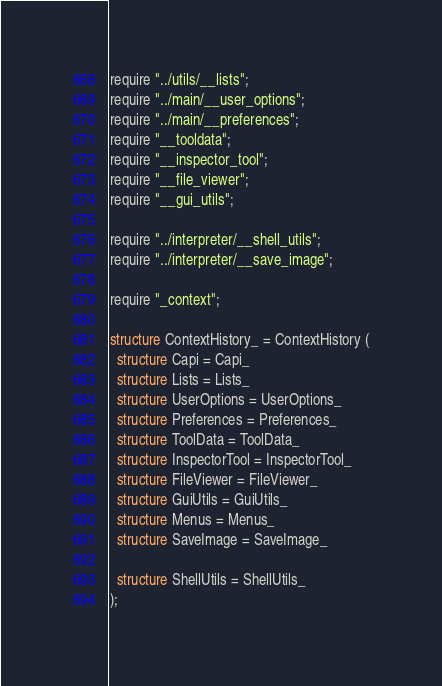<code> <loc_0><loc_0><loc_500><loc_500><_SML_>require "../utils/__lists";
require "../main/__user_options";
require "../main/__preferences";
require "__tooldata";
require "__inspector_tool";
require "__file_viewer";
require "__gui_utils";

require "../interpreter/__shell_utils";
require "../interpreter/__save_image";

require "_context";

structure ContextHistory_ = ContextHistory (
  structure Capi = Capi_
  structure Lists = Lists_
  structure UserOptions = UserOptions_
  structure Preferences = Preferences_
  structure ToolData = ToolData_
  structure InspectorTool = InspectorTool_
  structure FileViewer = FileViewer_
  structure GuiUtils = GuiUtils_
  structure Menus = Menus_
  structure SaveImage = SaveImage_

  structure ShellUtils = ShellUtils_
);
</code> 